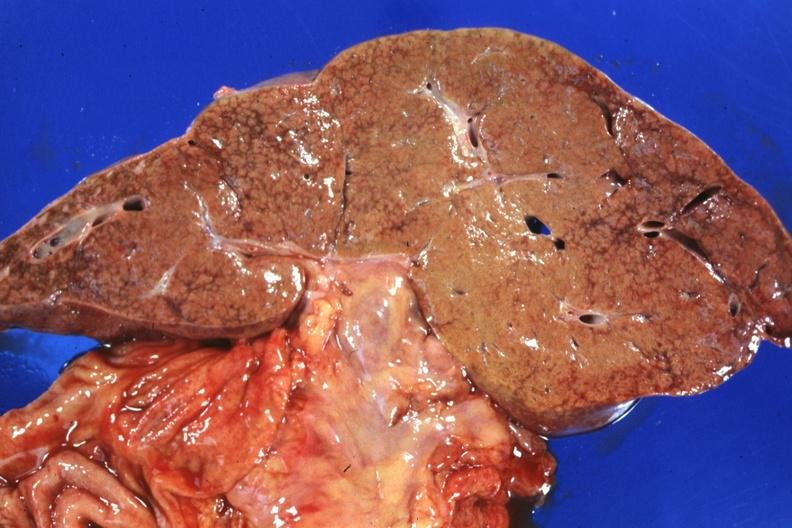what is present?
Answer the question using a single word or phrase. Liver 